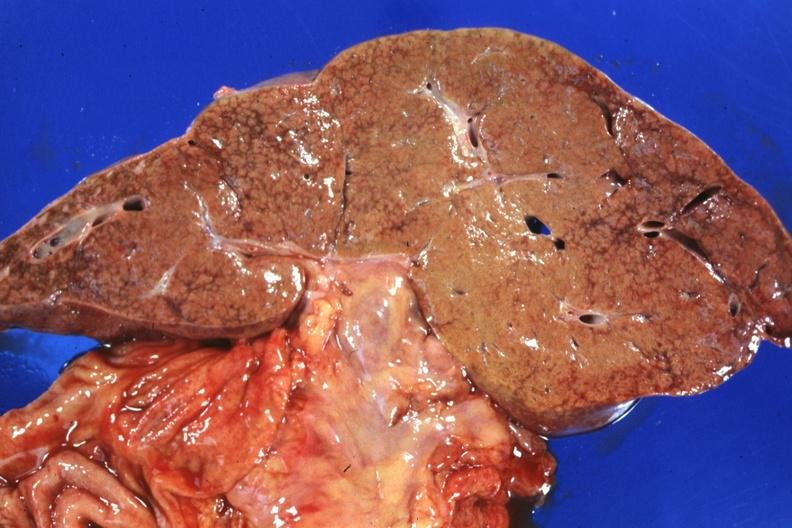what is present?
Answer the question using a single word or phrase. Liver 